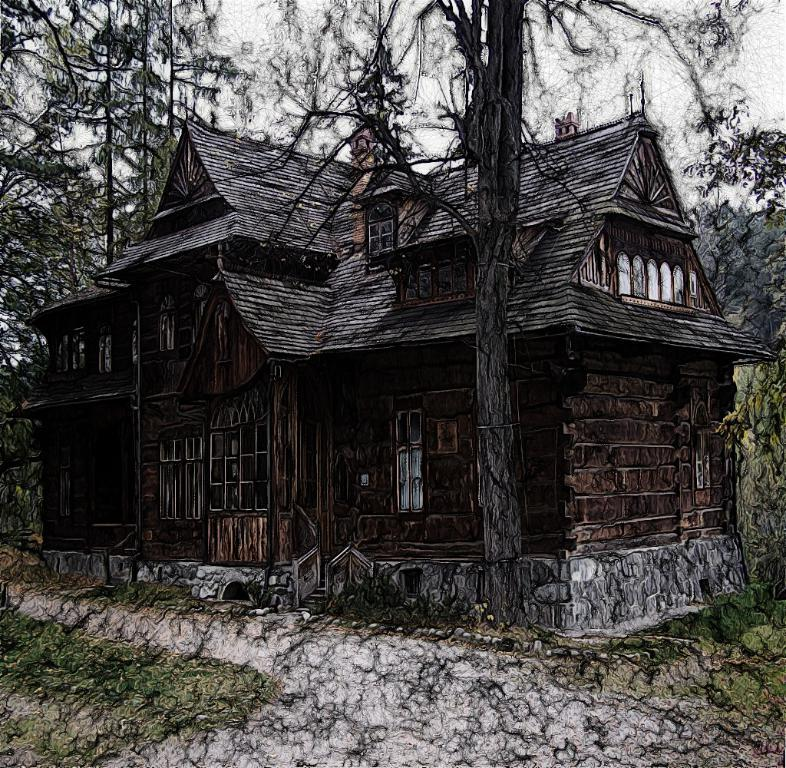What type of structure is present in the picture? There is a house in the picture. What part of the house can be used for entering or exiting? There is a door in the picture. What feature of the house allows natural light to enter? There are windows in the picture. What type of vegetation is visible in the picture? There are trees in the picture. What is visible above the house and trees in the picture? The sky is visible in the picture. What type of hose is being used for the journey in the picture? There is no hose or journey present in the picture; it features a house with a door, windows, trees, and a visible sky. 